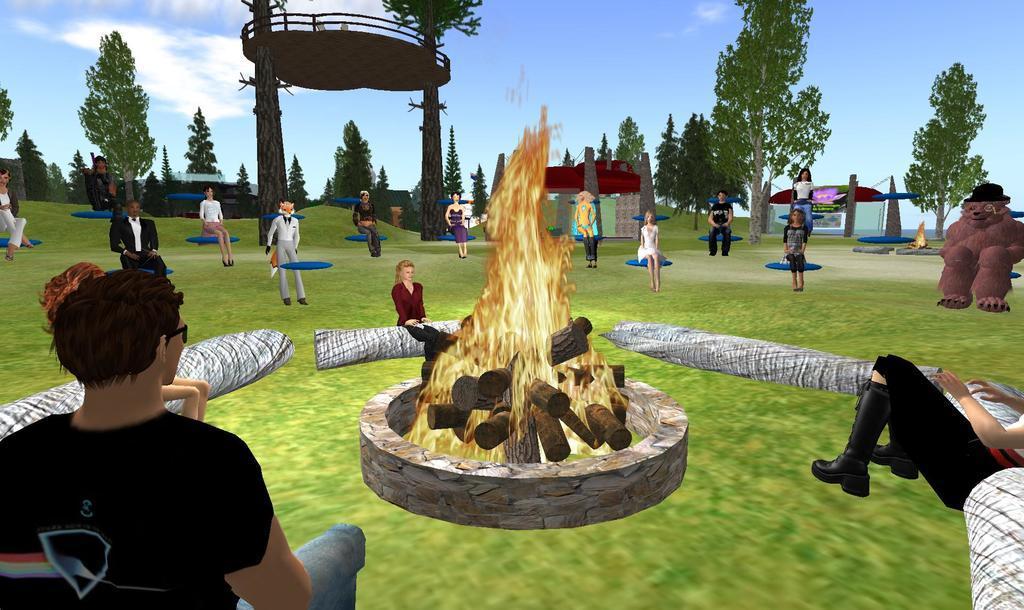Can you describe this image briefly? In the image we can see animated picture of people standing and some of them are sitting. Here we can see bonfire, trees and the sky. 